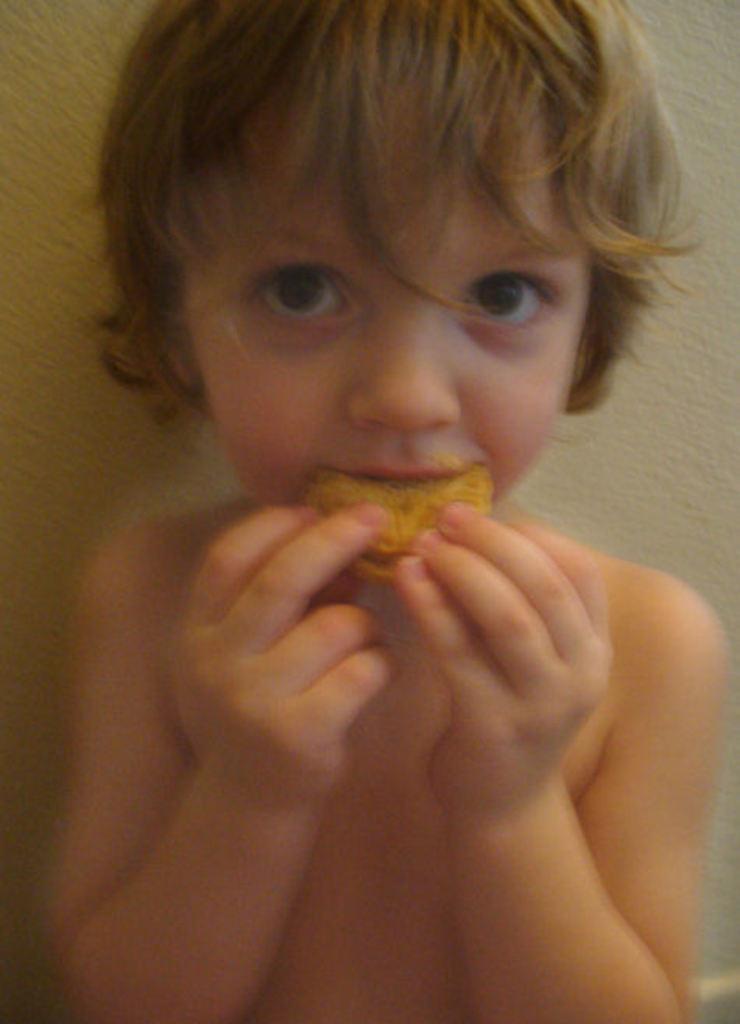Please provide a concise description of this image. In this image there is a kid holding some food. He is eating the food. Background there is a wall. 